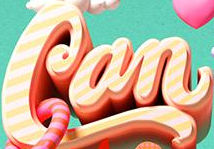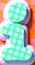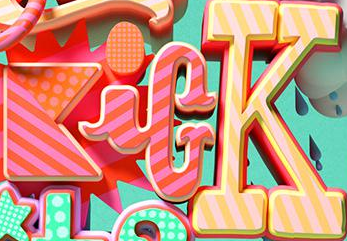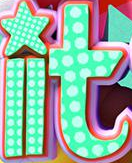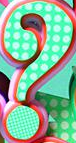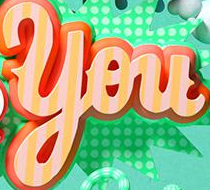What text is displayed in these images sequentially, separated by a semicolon? Can; i; KicK; it; ?; You 